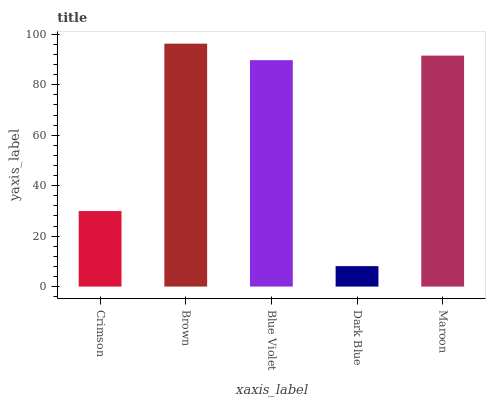Is Dark Blue the minimum?
Answer yes or no. Yes. Is Brown the maximum?
Answer yes or no. Yes. Is Blue Violet the minimum?
Answer yes or no. No. Is Blue Violet the maximum?
Answer yes or no. No. Is Brown greater than Blue Violet?
Answer yes or no. Yes. Is Blue Violet less than Brown?
Answer yes or no. Yes. Is Blue Violet greater than Brown?
Answer yes or no. No. Is Brown less than Blue Violet?
Answer yes or no. No. Is Blue Violet the high median?
Answer yes or no. Yes. Is Blue Violet the low median?
Answer yes or no. Yes. Is Brown the high median?
Answer yes or no. No. Is Dark Blue the low median?
Answer yes or no. No. 